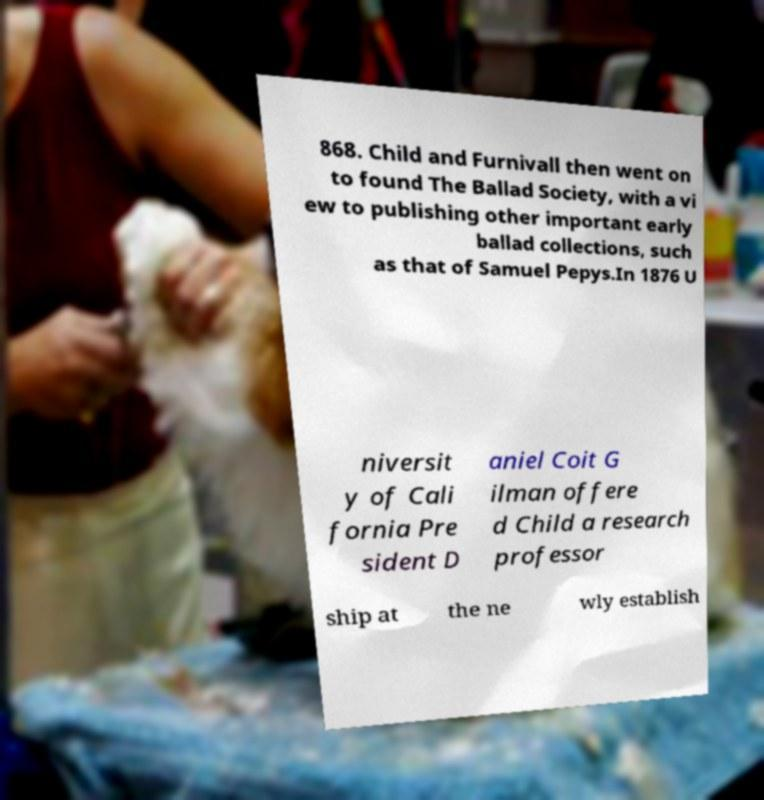What messages or text are displayed in this image? I need them in a readable, typed format. 868. Child and Furnivall then went on to found The Ballad Society, with a vi ew to publishing other important early ballad collections, such as that of Samuel Pepys.In 1876 U niversit y of Cali fornia Pre sident D aniel Coit G ilman offere d Child a research professor ship at the ne wly establish 